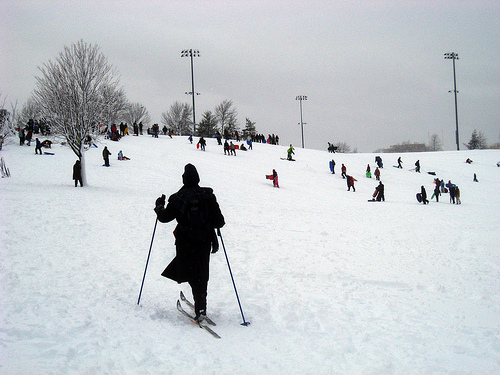What kind of challenges might people face in such a snowy environment? In a snowy environment like this, people might face challenges such as keeping balance on slippery surfaces, staying warm in freezing temperatures, and ensuring they have the right equipment to navigate the snowy terrain safely. Weather conditions can also change rapidly, making it important to be prepared for sudden snowstorms or strong winds. Describe a day in the life of someone who frequents this place. For someone who frequents this snowy landscape, a typical day might start early in the morning with a hearty breakfast to fuel up for the day ahead. They would check their gear and ensure they are dressed warmly, with layers of clothing to protect against the cold. Heading out to the slopes, they might spend hours skiing or snowboarding, enjoying the thrill of the snow and the crisp, fresh air. They might take breaks with friends or family at a cozy lodge, sipping hot drinks and sharing stories of their day’s adventures. As the sun sets, they would head back, perhaps participating in a community event or relaxing by a fireplace, reflecting on another exhilarating day spent in the snowy wonderland. What would be an unexpected, magical occurrence in this setting? An unexpected, magical occurrence in this setting would be the sudden appearance of the Northern Lights, painting the night sky with vibrant greens, purples, and blues. The entire snowy landscape would be bathed in an ethereal glow, with people pausing in awe to witness the breathtaking spectacle. It would be a moment of pure wonder and enchantment, adding a mystical touch to the wintry scene. 